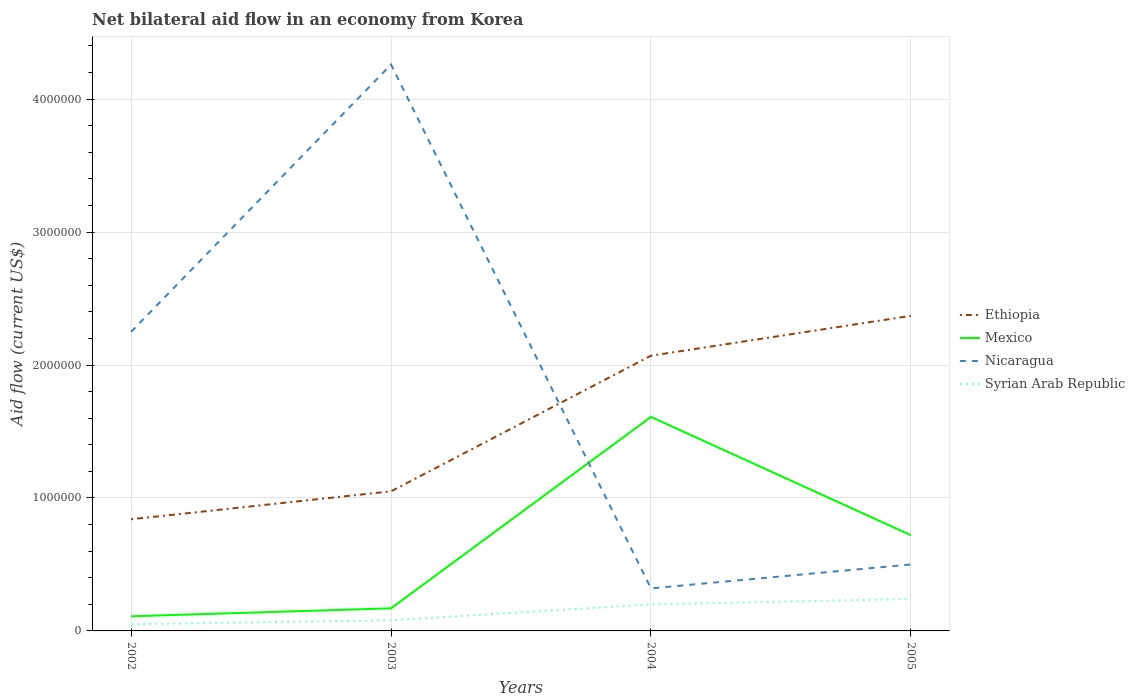Is the number of lines equal to the number of legend labels?
Provide a short and direct response. Yes. Across all years, what is the maximum net bilateral aid flow in Ethiopia?
Give a very brief answer. 8.40e+05. In which year was the net bilateral aid flow in Mexico maximum?
Provide a short and direct response. 2002. What is the total net bilateral aid flow in Ethiopia in the graph?
Your response must be concise. -1.53e+06. Is the net bilateral aid flow in Ethiopia strictly greater than the net bilateral aid flow in Syrian Arab Republic over the years?
Provide a succinct answer. No. How many years are there in the graph?
Provide a succinct answer. 4. Are the values on the major ticks of Y-axis written in scientific E-notation?
Provide a short and direct response. No. How many legend labels are there?
Give a very brief answer. 4. How are the legend labels stacked?
Offer a very short reply. Vertical. What is the title of the graph?
Make the answer very short. Net bilateral aid flow in an economy from Korea. What is the label or title of the X-axis?
Give a very brief answer. Years. What is the Aid flow (current US$) in Ethiopia in 2002?
Offer a terse response. 8.40e+05. What is the Aid flow (current US$) of Mexico in 2002?
Your response must be concise. 1.10e+05. What is the Aid flow (current US$) in Nicaragua in 2002?
Keep it short and to the point. 2.25e+06. What is the Aid flow (current US$) of Ethiopia in 2003?
Provide a short and direct response. 1.05e+06. What is the Aid flow (current US$) in Mexico in 2003?
Ensure brevity in your answer.  1.70e+05. What is the Aid flow (current US$) in Nicaragua in 2003?
Your answer should be compact. 4.26e+06. What is the Aid flow (current US$) of Syrian Arab Republic in 2003?
Give a very brief answer. 8.00e+04. What is the Aid flow (current US$) of Ethiopia in 2004?
Your response must be concise. 2.07e+06. What is the Aid flow (current US$) in Mexico in 2004?
Make the answer very short. 1.61e+06. What is the Aid flow (current US$) in Nicaragua in 2004?
Your answer should be compact. 3.20e+05. What is the Aid flow (current US$) in Ethiopia in 2005?
Keep it short and to the point. 2.37e+06. What is the Aid flow (current US$) of Mexico in 2005?
Give a very brief answer. 7.20e+05. What is the Aid flow (current US$) in Nicaragua in 2005?
Your response must be concise. 5.00e+05. Across all years, what is the maximum Aid flow (current US$) in Ethiopia?
Your answer should be very brief. 2.37e+06. Across all years, what is the maximum Aid flow (current US$) in Mexico?
Make the answer very short. 1.61e+06. Across all years, what is the maximum Aid flow (current US$) of Nicaragua?
Offer a very short reply. 4.26e+06. Across all years, what is the minimum Aid flow (current US$) in Ethiopia?
Your answer should be compact. 8.40e+05. Across all years, what is the minimum Aid flow (current US$) in Mexico?
Give a very brief answer. 1.10e+05. Across all years, what is the minimum Aid flow (current US$) in Nicaragua?
Make the answer very short. 3.20e+05. What is the total Aid flow (current US$) of Ethiopia in the graph?
Offer a terse response. 6.33e+06. What is the total Aid flow (current US$) of Mexico in the graph?
Provide a short and direct response. 2.61e+06. What is the total Aid flow (current US$) of Nicaragua in the graph?
Give a very brief answer. 7.33e+06. What is the total Aid flow (current US$) of Syrian Arab Republic in the graph?
Offer a very short reply. 5.70e+05. What is the difference between the Aid flow (current US$) in Ethiopia in 2002 and that in 2003?
Provide a short and direct response. -2.10e+05. What is the difference between the Aid flow (current US$) in Mexico in 2002 and that in 2003?
Offer a very short reply. -6.00e+04. What is the difference between the Aid flow (current US$) in Nicaragua in 2002 and that in 2003?
Your answer should be compact. -2.01e+06. What is the difference between the Aid flow (current US$) of Ethiopia in 2002 and that in 2004?
Your answer should be very brief. -1.23e+06. What is the difference between the Aid flow (current US$) in Mexico in 2002 and that in 2004?
Keep it short and to the point. -1.50e+06. What is the difference between the Aid flow (current US$) in Nicaragua in 2002 and that in 2004?
Your response must be concise. 1.93e+06. What is the difference between the Aid flow (current US$) in Ethiopia in 2002 and that in 2005?
Your answer should be very brief. -1.53e+06. What is the difference between the Aid flow (current US$) in Mexico in 2002 and that in 2005?
Make the answer very short. -6.10e+05. What is the difference between the Aid flow (current US$) in Nicaragua in 2002 and that in 2005?
Keep it short and to the point. 1.75e+06. What is the difference between the Aid flow (current US$) in Syrian Arab Republic in 2002 and that in 2005?
Provide a short and direct response. -1.90e+05. What is the difference between the Aid flow (current US$) of Ethiopia in 2003 and that in 2004?
Offer a terse response. -1.02e+06. What is the difference between the Aid flow (current US$) of Mexico in 2003 and that in 2004?
Provide a succinct answer. -1.44e+06. What is the difference between the Aid flow (current US$) of Nicaragua in 2003 and that in 2004?
Your answer should be compact. 3.94e+06. What is the difference between the Aid flow (current US$) in Syrian Arab Republic in 2003 and that in 2004?
Give a very brief answer. -1.20e+05. What is the difference between the Aid flow (current US$) in Ethiopia in 2003 and that in 2005?
Your response must be concise. -1.32e+06. What is the difference between the Aid flow (current US$) in Mexico in 2003 and that in 2005?
Give a very brief answer. -5.50e+05. What is the difference between the Aid flow (current US$) in Nicaragua in 2003 and that in 2005?
Give a very brief answer. 3.76e+06. What is the difference between the Aid flow (current US$) of Syrian Arab Republic in 2003 and that in 2005?
Ensure brevity in your answer.  -1.60e+05. What is the difference between the Aid flow (current US$) in Mexico in 2004 and that in 2005?
Provide a succinct answer. 8.90e+05. What is the difference between the Aid flow (current US$) of Ethiopia in 2002 and the Aid flow (current US$) of Mexico in 2003?
Provide a short and direct response. 6.70e+05. What is the difference between the Aid flow (current US$) in Ethiopia in 2002 and the Aid flow (current US$) in Nicaragua in 2003?
Provide a succinct answer. -3.42e+06. What is the difference between the Aid flow (current US$) in Ethiopia in 2002 and the Aid flow (current US$) in Syrian Arab Republic in 2003?
Your answer should be compact. 7.60e+05. What is the difference between the Aid flow (current US$) in Mexico in 2002 and the Aid flow (current US$) in Nicaragua in 2003?
Your answer should be very brief. -4.15e+06. What is the difference between the Aid flow (current US$) in Mexico in 2002 and the Aid flow (current US$) in Syrian Arab Republic in 2003?
Keep it short and to the point. 3.00e+04. What is the difference between the Aid flow (current US$) of Nicaragua in 2002 and the Aid flow (current US$) of Syrian Arab Republic in 2003?
Ensure brevity in your answer.  2.17e+06. What is the difference between the Aid flow (current US$) of Ethiopia in 2002 and the Aid flow (current US$) of Mexico in 2004?
Ensure brevity in your answer.  -7.70e+05. What is the difference between the Aid flow (current US$) in Ethiopia in 2002 and the Aid flow (current US$) in Nicaragua in 2004?
Ensure brevity in your answer.  5.20e+05. What is the difference between the Aid flow (current US$) in Ethiopia in 2002 and the Aid flow (current US$) in Syrian Arab Republic in 2004?
Offer a very short reply. 6.40e+05. What is the difference between the Aid flow (current US$) in Mexico in 2002 and the Aid flow (current US$) in Syrian Arab Republic in 2004?
Your response must be concise. -9.00e+04. What is the difference between the Aid flow (current US$) in Nicaragua in 2002 and the Aid flow (current US$) in Syrian Arab Republic in 2004?
Offer a very short reply. 2.05e+06. What is the difference between the Aid flow (current US$) in Ethiopia in 2002 and the Aid flow (current US$) in Nicaragua in 2005?
Offer a very short reply. 3.40e+05. What is the difference between the Aid flow (current US$) of Mexico in 2002 and the Aid flow (current US$) of Nicaragua in 2005?
Your response must be concise. -3.90e+05. What is the difference between the Aid flow (current US$) in Nicaragua in 2002 and the Aid flow (current US$) in Syrian Arab Republic in 2005?
Give a very brief answer. 2.01e+06. What is the difference between the Aid flow (current US$) of Ethiopia in 2003 and the Aid flow (current US$) of Mexico in 2004?
Your response must be concise. -5.60e+05. What is the difference between the Aid flow (current US$) of Ethiopia in 2003 and the Aid flow (current US$) of Nicaragua in 2004?
Offer a very short reply. 7.30e+05. What is the difference between the Aid flow (current US$) in Ethiopia in 2003 and the Aid flow (current US$) in Syrian Arab Republic in 2004?
Your answer should be compact. 8.50e+05. What is the difference between the Aid flow (current US$) of Mexico in 2003 and the Aid flow (current US$) of Syrian Arab Republic in 2004?
Provide a short and direct response. -3.00e+04. What is the difference between the Aid flow (current US$) in Nicaragua in 2003 and the Aid flow (current US$) in Syrian Arab Republic in 2004?
Your answer should be very brief. 4.06e+06. What is the difference between the Aid flow (current US$) in Ethiopia in 2003 and the Aid flow (current US$) in Syrian Arab Republic in 2005?
Your answer should be very brief. 8.10e+05. What is the difference between the Aid flow (current US$) in Mexico in 2003 and the Aid flow (current US$) in Nicaragua in 2005?
Ensure brevity in your answer.  -3.30e+05. What is the difference between the Aid flow (current US$) of Nicaragua in 2003 and the Aid flow (current US$) of Syrian Arab Republic in 2005?
Give a very brief answer. 4.02e+06. What is the difference between the Aid flow (current US$) in Ethiopia in 2004 and the Aid flow (current US$) in Mexico in 2005?
Your response must be concise. 1.35e+06. What is the difference between the Aid flow (current US$) of Ethiopia in 2004 and the Aid flow (current US$) of Nicaragua in 2005?
Your answer should be compact. 1.57e+06. What is the difference between the Aid flow (current US$) of Ethiopia in 2004 and the Aid flow (current US$) of Syrian Arab Republic in 2005?
Give a very brief answer. 1.83e+06. What is the difference between the Aid flow (current US$) of Mexico in 2004 and the Aid flow (current US$) of Nicaragua in 2005?
Ensure brevity in your answer.  1.11e+06. What is the difference between the Aid flow (current US$) in Mexico in 2004 and the Aid flow (current US$) in Syrian Arab Republic in 2005?
Provide a short and direct response. 1.37e+06. What is the average Aid flow (current US$) in Ethiopia per year?
Provide a short and direct response. 1.58e+06. What is the average Aid flow (current US$) of Mexico per year?
Make the answer very short. 6.52e+05. What is the average Aid flow (current US$) in Nicaragua per year?
Offer a terse response. 1.83e+06. What is the average Aid flow (current US$) of Syrian Arab Republic per year?
Give a very brief answer. 1.42e+05. In the year 2002, what is the difference between the Aid flow (current US$) in Ethiopia and Aid flow (current US$) in Mexico?
Offer a terse response. 7.30e+05. In the year 2002, what is the difference between the Aid flow (current US$) in Ethiopia and Aid flow (current US$) in Nicaragua?
Offer a terse response. -1.41e+06. In the year 2002, what is the difference between the Aid flow (current US$) in Ethiopia and Aid flow (current US$) in Syrian Arab Republic?
Your response must be concise. 7.90e+05. In the year 2002, what is the difference between the Aid flow (current US$) in Mexico and Aid flow (current US$) in Nicaragua?
Offer a very short reply. -2.14e+06. In the year 2002, what is the difference between the Aid flow (current US$) of Mexico and Aid flow (current US$) of Syrian Arab Republic?
Your answer should be compact. 6.00e+04. In the year 2002, what is the difference between the Aid flow (current US$) in Nicaragua and Aid flow (current US$) in Syrian Arab Republic?
Your response must be concise. 2.20e+06. In the year 2003, what is the difference between the Aid flow (current US$) in Ethiopia and Aid flow (current US$) in Mexico?
Provide a succinct answer. 8.80e+05. In the year 2003, what is the difference between the Aid flow (current US$) of Ethiopia and Aid flow (current US$) of Nicaragua?
Your response must be concise. -3.21e+06. In the year 2003, what is the difference between the Aid flow (current US$) in Ethiopia and Aid flow (current US$) in Syrian Arab Republic?
Your answer should be very brief. 9.70e+05. In the year 2003, what is the difference between the Aid flow (current US$) of Mexico and Aid flow (current US$) of Nicaragua?
Provide a succinct answer. -4.09e+06. In the year 2003, what is the difference between the Aid flow (current US$) of Mexico and Aid flow (current US$) of Syrian Arab Republic?
Keep it short and to the point. 9.00e+04. In the year 2003, what is the difference between the Aid flow (current US$) in Nicaragua and Aid flow (current US$) in Syrian Arab Republic?
Your answer should be compact. 4.18e+06. In the year 2004, what is the difference between the Aid flow (current US$) of Ethiopia and Aid flow (current US$) of Mexico?
Offer a terse response. 4.60e+05. In the year 2004, what is the difference between the Aid flow (current US$) of Ethiopia and Aid flow (current US$) of Nicaragua?
Ensure brevity in your answer.  1.75e+06. In the year 2004, what is the difference between the Aid flow (current US$) in Ethiopia and Aid flow (current US$) in Syrian Arab Republic?
Give a very brief answer. 1.87e+06. In the year 2004, what is the difference between the Aid flow (current US$) of Mexico and Aid flow (current US$) of Nicaragua?
Keep it short and to the point. 1.29e+06. In the year 2004, what is the difference between the Aid flow (current US$) in Mexico and Aid flow (current US$) in Syrian Arab Republic?
Offer a terse response. 1.41e+06. In the year 2005, what is the difference between the Aid flow (current US$) of Ethiopia and Aid flow (current US$) of Mexico?
Ensure brevity in your answer.  1.65e+06. In the year 2005, what is the difference between the Aid flow (current US$) of Ethiopia and Aid flow (current US$) of Nicaragua?
Ensure brevity in your answer.  1.87e+06. In the year 2005, what is the difference between the Aid flow (current US$) in Ethiopia and Aid flow (current US$) in Syrian Arab Republic?
Ensure brevity in your answer.  2.13e+06. In the year 2005, what is the difference between the Aid flow (current US$) of Mexico and Aid flow (current US$) of Syrian Arab Republic?
Ensure brevity in your answer.  4.80e+05. In the year 2005, what is the difference between the Aid flow (current US$) in Nicaragua and Aid flow (current US$) in Syrian Arab Republic?
Offer a very short reply. 2.60e+05. What is the ratio of the Aid flow (current US$) in Ethiopia in 2002 to that in 2003?
Your answer should be compact. 0.8. What is the ratio of the Aid flow (current US$) of Mexico in 2002 to that in 2003?
Offer a terse response. 0.65. What is the ratio of the Aid flow (current US$) in Nicaragua in 2002 to that in 2003?
Your answer should be very brief. 0.53. What is the ratio of the Aid flow (current US$) in Syrian Arab Republic in 2002 to that in 2003?
Your answer should be compact. 0.62. What is the ratio of the Aid flow (current US$) in Ethiopia in 2002 to that in 2004?
Your response must be concise. 0.41. What is the ratio of the Aid flow (current US$) in Mexico in 2002 to that in 2004?
Keep it short and to the point. 0.07. What is the ratio of the Aid flow (current US$) of Nicaragua in 2002 to that in 2004?
Provide a short and direct response. 7.03. What is the ratio of the Aid flow (current US$) in Ethiopia in 2002 to that in 2005?
Give a very brief answer. 0.35. What is the ratio of the Aid flow (current US$) in Mexico in 2002 to that in 2005?
Offer a terse response. 0.15. What is the ratio of the Aid flow (current US$) of Syrian Arab Republic in 2002 to that in 2005?
Your response must be concise. 0.21. What is the ratio of the Aid flow (current US$) in Ethiopia in 2003 to that in 2004?
Offer a very short reply. 0.51. What is the ratio of the Aid flow (current US$) of Mexico in 2003 to that in 2004?
Your answer should be compact. 0.11. What is the ratio of the Aid flow (current US$) of Nicaragua in 2003 to that in 2004?
Give a very brief answer. 13.31. What is the ratio of the Aid flow (current US$) in Syrian Arab Republic in 2003 to that in 2004?
Provide a short and direct response. 0.4. What is the ratio of the Aid flow (current US$) of Ethiopia in 2003 to that in 2005?
Your answer should be compact. 0.44. What is the ratio of the Aid flow (current US$) of Mexico in 2003 to that in 2005?
Keep it short and to the point. 0.24. What is the ratio of the Aid flow (current US$) of Nicaragua in 2003 to that in 2005?
Your answer should be very brief. 8.52. What is the ratio of the Aid flow (current US$) of Ethiopia in 2004 to that in 2005?
Make the answer very short. 0.87. What is the ratio of the Aid flow (current US$) in Mexico in 2004 to that in 2005?
Offer a very short reply. 2.24. What is the ratio of the Aid flow (current US$) in Nicaragua in 2004 to that in 2005?
Ensure brevity in your answer.  0.64. What is the ratio of the Aid flow (current US$) of Syrian Arab Republic in 2004 to that in 2005?
Give a very brief answer. 0.83. What is the difference between the highest and the second highest Aid flow (current US$) of Ethiopia?
Provide a short and direct response. 3.00e+05. What is the difference between the highest and the second highest Aid flow (current US$) of Mexico?
Your answer should be compact. 8.90e+05. What is the difference between the highest and the second highest Aid flow (current US$) in Nicaragua?
Your answer should be very brief. 2.01e+06. What is the difference between the highest and the lowest Aid flow (current US$) of Ethiopia?
Offer a very short reply. 1.53e+06. What is the difference between the highest and the lowest Aid flow (current US$) in Mexico?
Provide a short and direct response. 1.50e+06. What is the difference between the highest and the lowest Aid flow (current US$) in Nicaragua?
Give a very brief answer. 3.94e+06. What is the difference between the highest and the lowest Aid flow (current US$) of Syrian Arab Republic?
Ensure brevity in your answer.  1.90e+05. 